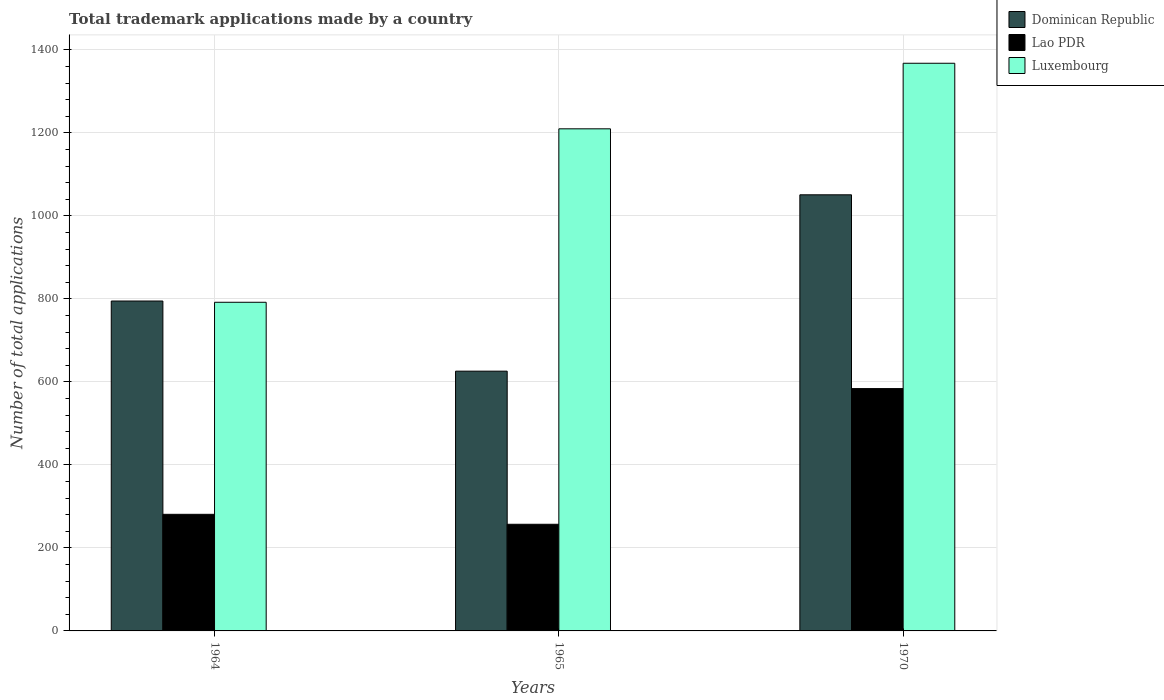How many different coloured bars are there?
Give a very brief answer. 3. How many groups of bars are there?
Your response must be concise. 3. How many bars are there on the 2nd tick from the left?
Offer a terse response. 3. How many bars are there on the 3rd tick from the right?
Your answer should be very brief. 3. What is the label of the 3rd group of bars from the left?
Offer a terse response. 1970. What is the number of applications made by in Lao PDR in 1965?
Ensure brevity in your answer.  257. Across all years, what is the maximum number of applications made by in Dominican Republic?
Your answer should be very brief. 1051. Across all years, what is the minimum number of applications made by in Lao PDR?
Make the answer very short. 257. In which year was the number of applications made by in Dominican Republic minimum?
Ensure brevity in your answer.  1965. What is the total number of applications made by in Luxembourg in the graph?
Offer a very short reply. 3370. What is the difference between the number of applications made by in Dominican Republic in 1964 and that in 1970?
Make the answer very short. -256. What is the difference between the number of applications made by in Lao PDR in 1965 and the number of applications made by in Dominican Republic in 1964?
Keep it short and to the point. -538. What is the average number of applications made by in Luxembourg per year?
Your answer should be very brief. 1123.33. In the year 1965, what is the difference between the number of applications made by in Lao PDR and number of applications made by in Dominican Republic?
Offer a very short reply. -369. In how many years, is the number of applications made by in Dominican Republic greater than 800?
Offer a very short reply. 1. What is the ratio of the number of applications made by in Luxembourg in 1964 to that in 1970?
Give a very brief answer. 0.58. Is the number of applications made by in Lao PDR in 1964 less than that in 1970?
Ensure brevity in your answer.  Yes. What is the difference between the highest and the second highest number of applications made by in Lao PDR?
Provide a short and direct response. 303. What is the difference between the highest and the lowest number of applications made by in Dominican Republic?
Your answer should be compact. 425. In how many years, is the number of applications made by in Dominican Republic greater than the average number of applications made by in Dominican Republic taken over all years?
Give a very brief answer. 1. Is the sum of the number of applications made by in Lao PDR in 1965 and 1970 greater than the maximum number of applications made by in Luxembourg across all years?
Make the answer very short. No. What does the 1st bar from the left in 1964 represents?
Offer a very short reply. Dominican Republic. What does the 3rd bar from the right in 1964 represents?
Ensure brevity in your answer.  Dominican Republic. Are all the bars in the graph horizontal?
Your answer should be very brief. No. How many years are there in the graph?
Your answer should be very brief. 3. Does the graph contain grids?
Offer a terse response. Yes. How many legend labels are there?
Provide a short and direct response. 3. What is the title of the graph?
Provide a short and direct response. Total trademark applications made by a country. What is the label or title of the Y-axis?
Provide a succinct answer. Number of total applications. What is the Number of total applications of Dominican Republic in 1964?
Your response must be concise. 795. What is the Number of total applications in Lao PDR in 1964?
Make the answer very short. 281. What is the Number of total applications of Luxembourg in 1964?
Ensure brevity in your answer.  792. What is the Number of total applications in Dominican Republic in 1965?
Ensure brevity in your answer.  626. What is the Number of total applications of Lao PDR in 1965?
Your response must be concise. 257. What is the Number of total applications in Luxembourg in 1965?
Offer a terse response. 1210. What is the Number of total applications in Dominican Republic in 1970?
Your answer should be compact. 1051. What is the Number of total applications in Lao PDR in 1970?
Your response must be concise. 584. What is the Number of total applications of Luxembourg in 1970?
Offer a terse response. 1368. Across all years, what is the maximum Number of total applications of Dominican Republic?
Offer a very short reply. 1051. Across all years, what is the maximum Number of total applications of Lao PDR?
Provide a short and direct response. 584. Across all years, what is the maximum Number of total applications in Luxembourg?
Keep it short and to the point. 1368. Across all years, what is the minimum Number of total applications of Dominican Republic?
Your answer should be very brief. 626. Across all years, what is the minimum Number of total applications in Lao PDR?
Keep it short and to the point. 257. Across all years, what is the minimum Number of total applications of Luxembourg?
Keep it short and to the point. 792. What is the total Number of total applications in Dominican Republic in the graph?
Your response must be concise. 2472. What is the total Number of total applications in Lao PDR in the graph?
Make the answer very short. 1122. What is the total Number of total applications in Luxembourg in the graph?
Ensure brevity in your answer.  3370. What is the difference between the Number of total applications of Dominican Republic in 1964 and that in 1965?
Make the answer very short. 169. What is the difference between the Number of total applications of Lao PDR in 1964 and that in 1965?
Your answer should be compact. 24. What is the difference between the Number of total applications of Luxembourg in 1964 and that in 1965?
Provide a short and direct response. -418. What is the difference between the Number of total applications of Dominican Republic in 1964 and that in 1970?
Your answer should be very brief. -256. What is the difference between the Number of total applications of Lao PDR in 1964 and that in 1970?
Your answer should be compact. -303. What is the difference between the Number of total applications of Luxembourg in 1964 and that in 1970?
Ensure brevity in your answer.  -576. What is the difference between the Number of total applications in Dominican Republic in 1965 and that in 1970?
Your response must be concise. -425. What is the difference between the Number of total applications in Lao PDR in 1965 and that in 1970?
Provide a short and direct response. -327. What is the difference between the Number of total applications of Luxembourg in 1965 and that in 1970?
Offer a very short reply. -158. What is the difference between the Number of total applications of Dominican Republic in 1964 and the Number of total applications of Lao PDR in 1965?
Give a very brief answer. 538. What is the difference between the Number of total applications in Dominican Republic in 1964 and the Number of total applications in Luxembourg in 1965?
Your answer should be very brief. -415. What is the difference between the Number of total applications in Lao PDR in 1964 and the Number of total applications in Luxembourg in 1965?
Offer a very short reply. -929. What is the difference between the Number of total applications of Dominican Republic in 1964 and the Number of total applications of Lao PDR in 1970?
Keep it short and to the point. 211. What is the difference between the Number of total applications in Dominican Republic in 1964 and the Number of total applications in Luxembourg in 1970?
Keep it short and to the point. -573. What is the difference between the Number of total applications of Lao PDR in 1964 and the Number of total applications of Luxembourg in 1970?
Offer a terse response. -1087. What is the difference between the Number of total applications in Dominican Republic in 1965 and the Number of total applications in Lao PDR in 1970?
Give a very brief answer. 42. What is the difference between the Number of total applications of Dominican Republic in 1965 and the Number of total applications of Luxembourg in 1970?
Your response must be concise. -742. What is the difference between the Number of total applications of Lao PDR in 1965 and the Number of total applications of Luxembourg in 1970?
Provide a succinct answer. -1111. What is the average Number of total applications in Dominican Republic per year?
Your answer should be very brief. 824. What is the average Number of total applications in Lao PDR per year?
Make the answer very short. 374. What is the average Number of total applications in Luxembourg per year?
Offer a terse response. 1123.33. In the year 1964, what is the difference between the Number of total applications in Dominican Republic and Number of total applications in Lao PDR?
Your answer should be compact. 514. In the year 1964, what is the difference between the Number of total applications in Lao PDR and Number of total applications in Luxembourg?
Your response must be concise. -511. In the year 1965, what is the difference between the Number of total applications of Dominican Republic and Number of total applications of Lao PDR?
Your answer should be compact. 369. In the year 1965, what is the difference between the Number of total applications of Dominican Republic and Number of total applications of Luxembourg?
Give a very brief answer. -584. In the year 1965, what is the difference between the Number of total applications in Lao PDR and Number of total applications in Luxembourg?
Your answer should be very brief. -953. In the year 1970, what is the difference between the Number of total applications in Dominican Republic and Number of total applications in Lao PDR?
Make the answer very short. 467. In the year 1970, what is the difference between the Number of total applications of Dominican Republic and Number of total applications of Luxembourg?
Offer a very short reply. -317. In the year 1970, what is the difference between the Number of total applications of Lao PDR and Number of total applications of Luxembourg?
Make the answer very short. -784. What is the ratio of the Number of total applications in Dominican Republic in 1964 to that in 1965?
Offer a terse response. 1.27. What is the ratio of the Number of total applications of Lao PDR in 1964 to that in 1965?
Your answer should be very brief. 1.09. What is the ratio of the Number of total applications of Luxembourg in 1964 to that in 1965?
Make the answer very short. 0.65. What is the ratio of the Number of total applications of Dominican Republic in 1964 to that in 1970?
Your answer should be compact. 0.76. What is the ratio of the Number of total applications of Lao PDR in 1964 to that in 1970?
Offer a terse response. 0.48. What is the ratio of the Number of total applications in Luxembourg in 1964 to that in 1970?
Provide a succinct answer. 0.58. What is the ratio of the Number of total applications of Dominican Republic in 1965 to that in 1970?
Offer a terse response. 0.6. What is the ratio of the Number of total applications of Lao PDR in 1965 to that in 1970?
Give a very brief answer. 0.44. What is the ratio of the Number of total applications of Luxembourg in 1965 to that in 1970?
Your answer should be compact. 0.88. What is the difference between the highest and the second highest Number of total applications in Dominican Republic?
Keep it short and to the point. 256. What is the difference between the highest and the second highest Number of total applications of Lao PDR?
Your answer should be very brief. 303. What is the difference between the highest and the second highest Number of total applications in Luxembourg?
Your answer should be very brief. 158. What is the difference between the highest and the lowest Number of total applications in Dominican Republic?
Give a very brief answer. 425. What is the difference between the highest and the lowest Number of total applications of Lao PDR?
Offer a very short reply. 327. What is the difference between the highest and the lowest Number of total applications in Luxembourg?
Provide a short and direct response. 576. 